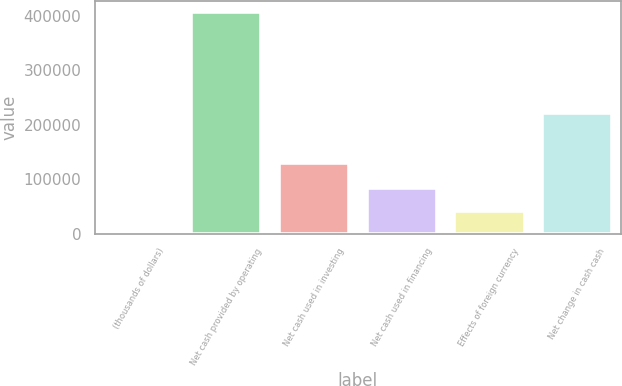<chart> <loc_0><loc_0><loc_500><loc_500><bar_chart><fcel>(thousands of dollars)<fcel>Net cash provided by operating<fcel>Net cash used in investing<fcel>Net cash used in financing<fcel>Effects of foreign currency<fcel>Net change in cash cash<nl><fcel>2017<fcel>407903<fcel>129030<fcel>83194.2<fcel>42605.6<fcel>221303<nl></chart> 